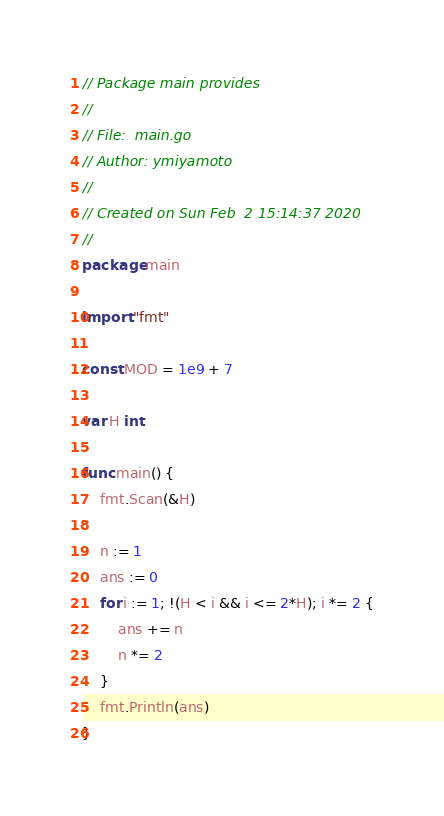Convert code to text. <code><loc_0><loc_0><loc_500><loc_500><_Go_>// Package main provides
//
// File:  main.go
// Author: ymiyamoto
//
// Created on Sun Feb  2 15:14:37 2020
//
package main

import "fmt"

const MOD = 1e9 + 7

var H int

func main() {
	fmt.Scan(&H)

	n := 1
	ans := 0
	for i := 1; !(H < i && i <= 2*H); i *= 2 {
		ans += n
		n *= 2
	}
	fmt.Println(ans)
}
</code> 